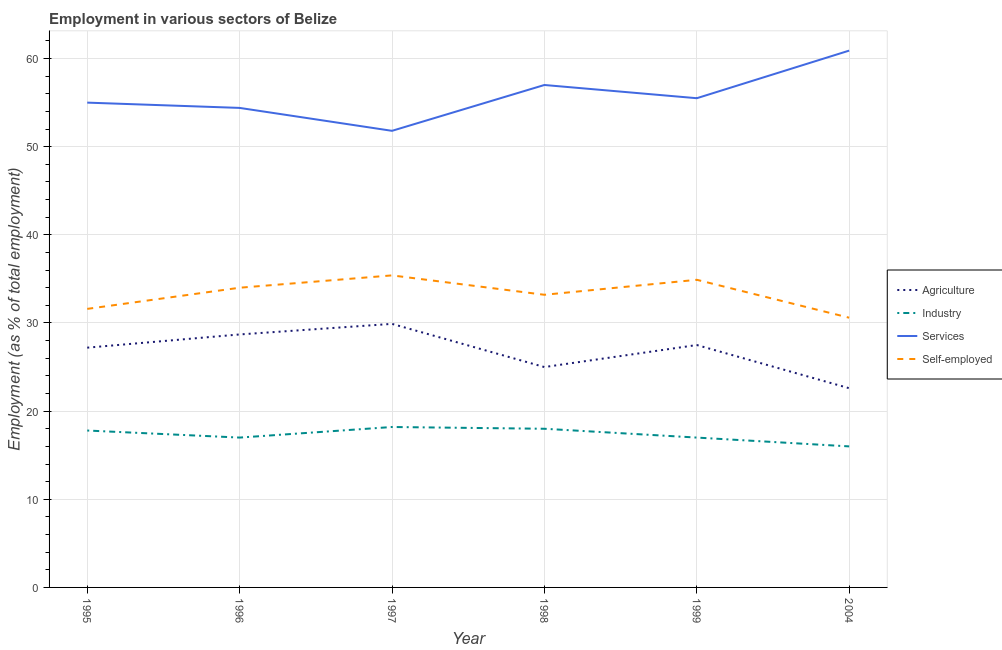Does the line corresponding to percentage of workers in services intersect with the line corresponding to percentage of workers in agriculture?
Ensure brevity in your answer.  No. What is the percentage of workers in industry in 1998?
Offer a very short reply. 18. Across all years, what is the maximum percentage of workers in services?
Ensure brevity in your answer.  60.9. Across all years, what is the minimum percentage of self employed workers?
Your response must be concise. 30.6. In which year was the percentage of self employed workers minimum?
Make the answer very short. 2004. What is the total percentage of self employed workers in the graph?
Offer a very short reply. 199.7. What is the difference between the percentage of self employed workers in 1998 and that in 1999?
Keep it short and to the point. -1.7. What is the difference between the percentage of workers in services in 1997 and the percentage of workers in industry in 2004?
Ensure brevity in your answer.  35.8. What is the average percentage of workers in industry per year?
Offer a very short reply. 17.33. In the year 1996, what is the difference between the percentage of workers in agriculture and percentage of workers in industry?
Provide a short and direct response. 11.7. What is the ratio of the percentage of self employed workers in 1995 to that in 1996?
Give a very brief answer. 0.93. Is the percentage of workers in services in 1995 less than that in 1996?
Keep it short and to the point. No. What is the difference between the highest and the second highest percentage of workers in agriculture?
Keep it short and to the point. 1.2. What is the difference between the highest and the lowest percentage of workers in industry?
Ensure brevity in your answer.  2.2. Is the percentage of self employed workers strictly greater than the percentage of workers in industry over the years?
Offer a very short reply. Yes. Is the percentage of workers in agriculture strictly less than the percentage of workers in industry over the years?
Your answer should be very brief. No. How many lines are there?
Provide a succinct answer. 4. How many years are there in the graph?
Keep it short and to the point. 6. What is the difference between two consecutive major ticks on the Y-axis?
Give a very brief answer. 10. Are the values on the major ticks of Y-axis written in scientific E-notation?
Offer a terse response. No. Does the graph contain any zero values?
Offer a very short reply. No. Where does the legend appear in the graph?
Offer a very short reply. Center right. What is the title of the graph?
Provide a short and direct response. Employment in various sectors of Belize. Does "Natural Gas" appear as one of the legend labels in the graph?
Offer a very short reply. No. What is the label or title of the X-axis?
Give a very brief answer. Year. What is the label or title of the Y-axis?
Give a very brief answer. Employment (as % of total employment). What is the Employment (as % of total employment) in Agriculture in 1995?
Ensure brevity in your answer.  27.2. What is the Employment (as % of total employment) in Industry in 1995?
Ensure brevity in your answer.  17.8. What is the Employment (as % of total employment) in Services in 1995?
Your answer should be compact. 55. What is the Employment (as % of total employment) in Self-employed in 1995?
Your answer should be compact. 31.6. What is the Employment (as % of total employment) in Agriculture in 1996?
Provide a short and direct response. 28.7. What is the Employment (as % of total employment) in Industry in 1996?
Offer a terse response. 17. What is the Employment (as % of total employment) of Services in 1996?
Your answer should be very brief. 54.4. What is the Employment (as % of total employment) in Agriculture in 1997?
Offer a very short reply. 29.9. What is the Employment (as % of total employment) in Industry in 1997?
Your answer should be compact. 18.2. What is the Employment (as % of total employment) of Services in 1997?
Provide a short and direct response. 51.8. What is the Employment (as % of total employment) in Self-employed in 1997?
Provide a succinct answer. 35.4. What is the Employment (as % of total employment) of Agriculture in 1998?
Provide a succinct answer. 25. What is the Employment (as % of total employment) of Industry in 1998?
Make the answer very short. 18. What is the Employment (as % of total employment) of Services in 1998?
Ensure brevity in your answer.  57. What is the Employment (as % of total employment) in Self-employed in 1998?
Your response must be concise. 33.2. What is the Employment (as % of total employment) in Agriculture in 1999?
Ensure brevity in your answer.  27.5. What is the Employment (as % of total employment) in Industry in 1999?
Make the answer very short. 17. What is the Employment (as % of total employment) of Services in 1999?
Provide a short and direct response. 55.5. What is the Employment (as % of total employment) in Self-employed in 1999?
Ensure brevity in your answer.  34.9. What is the Employment (as % of total employment) of Agriculture in 2004?
Make the answer very short. 22.6. What is the Employment (as % of total employment) in Industry in 2004?
Keep it short and to the point. 16. What is the Employment (as % of total employment) in Services in 2004?
Your response must be concise. 60.9. What is the Employment (as % of total employment) in Self-employed in 2004?
Give a very brief answer. 30.6. Across all years, what is the maximum Employment (as % of total employment) of Agriculture?
Offer a terse response. 29.9. Across all years, what is the maximum Employment (as % of total employment) in Industry?
Provide a succinct answer. 18.2. Across all years, what is the maximum Employment (as % of total employment) in Services?
Ensure brevity in your answer.  60.9. Across all years, what is the maximum Employment (as % of total employment) of Self-employed?
Your answer should be compact. 35.4. Across all years, what is the minimum Employment (as % of total employment) in Agriculture?
Make the answer very short. 22.6. Across all years, what is the minimum Employment (as % of total employment) in Services?
Keep it short and to the point. 51.8. Across all years, what is the minimum Employment (as % of total employment) in Self-employed?
Provide a short and direct response. 30.6. What is the total Employment (as % of total employment) in Agriculture in the graph?
Your response must be concise. 160.9. What is the total Employment (as % of total employment) of Industry in the graph?
Ensure brevity in your answer.  104. What is the total Employment (as % of total employment) in Services in the graph?
Your answer should be compact. 334.6. What is the total Employment (as % of total employment) in Self-employed in the graph?
Keep it short and to the point. 199.7. What is the difference between the Employment (as % of total employment) in Industry in 1995 and that in 1996?
Your answer should be very brief. 0.8. What is the difference between the Employment (as % of total employment) of Agriculture in 1995 and that in 1997?
Your answer should be very brief. -2.7. What is the difference between the Employment (as % of total employment) in Industry in 1995 and that in 1997?
Make the answer very short. -0.4. What is the difference between the Employment (as % of total employment) in Self-employed in 1995 and that in 1997?
Offer a very short reply. -3.8. What is the difference between the Employment (as % of total employment) in Agriculture in 1995 and that in 1998?
Ensure brevity in your answer.  2.2. What is the difference between the Employment (as % of total employment) of Industry in 1995 and that in 1998?
Make the answer very short. -0.2. What is the difference between the Employment (as % of total employment) in Services in 1995 and that in 1998?
Give a very brief answer. -2. What is the difference between the Employment (as % of total employment) of Self-employed in 1995 and that in 1998?
Your answer should be compact. -1.6. What is the difference between the Employment (as % of total employment) in Industry in 1995 and that in 1999?
Ensure brevity in your answer.  0.8. What is the difference between the Employment (as % of total employment) of Services in 1995 and that in 1999?
Your answer should be compact. -0.5. What is the difference between the Employment (as % of total employment) of Services in 1995 and that in 2004?
Ensure brevity in your answer.  -5.9. What is the difference between the Employment (as % of total employment) in Self-employed in 1995 and that in 2004?
Keep it short and to the point. 1. What is the difference between the Employment (as % of total employment) of Agriculture in 1996 and that in 1997?
Ensure brevity in your answer.  -1.2. What is the difference between the Employment (as % of total employment) of Industry in 1996 and that in 1997?
Ensure brevity in your answer.  -1.2. What is the difference between the Employment (as % of total employment) of Agriculture in 1996 and that in 1998?
Your answer should be compact. 3.7. What is the difference between the Employment (as % of total employment) in Services in 1996 and that in 1998?
Your answer should be compact. -2.6. What is the difference between the Employment (as % of total employment) of Agriculture in 1996 and that in 1999?
Your answer should be compact. 1.2. What is the difference between the Employment (as % of total employment) in Industry in 1996 and that in 1999?
Offer a terse response. 0. What is the difference between the Employment (as % of total employment) in Industry in 1996 and that in 2004?
Your answer should be compact. 1. What is the difference between the Employment (as % of total employment) in Industry in 1997 and that in 1998?
Your answer should be compact. 0.2. What is the difference between the Employment (as % of total employment) of Industry in 1997 and that in 1999?
Provide a succinct answer. 1.2. What is the difference between the Employment (as % of total employment) in Services in 1997 and that in 1999?
Provide a succinct answer. -3.7. What is the difference between the Employment (as % of total employment) of Services in 1997 and that in 2004?
Keep it short and to the point. -9.1. What is the difference between the Employment (as % of total employment) in Self-employed in 1997 and that in 2004?
Your response must be concise. 4.8. What is the difference between the Employment (as % of total employment) in Industry in 1998 and that in 1999?
Your answer should be compact. 1. What is the difference between the Employment (as % of total employment) of Services in 1998 and that in 1999?
Your answer should be very brief. 1.5. What is the difference between the Employment (as % of total employment) of Services in 1998 and that in 2004?
Give a very brief answer. -3.9. What is the difference between the Employment (as % of total employment) of Self-employed in 1998 and that in 2004?
Ensure brevity in your answer.  2.6. What is the difference between the Employment (as % of total employment) in Industry in 1999 and that in 2004?
Give a very brief answer. 1. What is the difference between the Employment (as % of total employment) in Services in 1999 and that in 2004?
Your response must be concise. -5.4. What is the difference between the Employment (as % of total employment) in Self-employed in 1999 and that in 2004?
Provide a short and direct response. 4.3. What is the difference between the Employment (as % of total employment) of Agriculture in 1995 and the Employment (as % of total employment) of Services in 1996?
Keep it short and to the point. -27.2. What is the difference between the Employment (as % of total employment) of Agriculture in 1995 and the Employment (as % of total employment) of Self-employed in 1996?
Offer a terse response. -6.8. What is the difference between the Employment (as % of total employment) of Industry in 1995 and the Employment (as % of total employment) of Services in 1996?
Offer a very short reply. -36.6. What is the difference between the Employment (as % of total employment) of Industry in 1995 and the Employment (as % of total employment) of Self-employed in 1996?
Your response must be concise. -16.2. What is the difference between the Employment (as % of total employment) of Services in 1995 and the Employment (as % of total employment) of Self-employed in 1996?
Your answer should be very brief. 21. What is the difference between the Employment (as % of total employment) of Agriculture in 1995 and the Employment (as % of total employment) of Industry in 1997?
Give a very brief answer. 9. What is the difference between the Employment (as % of total employment) of Agriculture in 1995 and the Employment (as % of total employment) of Services in 1997?
Your answer should be compact. -24.6. What is the difference between the Employment (as % of total employment) of Agriculture in 1995 and the Employment (as % of total employment) of Self-employed in 1997?
Your answer should be very brief. -8.2. What is the difference between the Employment (as % of total employment) of Industry in 1995 and the Employment (as % of total employment) of Services in 1997?
Provide a succinct answer. -34. What is the difference between the Employment (as % of total employment) of Industry in 1995 and the Employment (as % of total employment) of Self-employed in 1997?
Offer a very short reply. -17.6. What is the difference between the Employment (as % of total employment) in Services in 1995 and the Employment (as % of total employment) in Self-employed in 1997?
Make the answer very short. 19.6. What is the difference between the Employment (as % of total employment) in Agriculture in 1995 and the Employment (as % of total employment) in Services in 1998?
Provide a short and direct response. -29.8. What is the difference between the Employment (as % of total employment) in Industry in 1995 and the Employment (as % of total employment) in Services in 1998?
Offer a very short reply. -39.2. What is the difference between the Employment (as % of total employment) in Industry in 1995 and the Employment (as % of total employment) in Self-employed in 1998?
Provide a short and direct response. -15.4. What is the difference between the Employment (as % of total employment) of Services in 1995 and the Employment (as % of total employment) of Self-employed in 1998?
Ensure brevity in your answer.  21.8. What is the difference between the Employment (as % of total employment) in Agriculture in 1995 and the Employment (as % of total employment) in Industry in 1999?
Offer a very short reply. 10.2. What is the difference between the Employment (as % of total employment) in Agriculture in 1995 and the Employment (as % of total employment) in Services in 1999?
Offer a terse response. -28.3. What is the difference between the Employment (as % of total employment) of Agriculture in 1995 and the Employment (as % of total employment) of Self-employed in 1999?
Your response must be concise. -7.7. What is the difference between the Employment (as % of total employment) in Industry in 1995 and the Employment (as % of total employment) in Services in 1999?
Ensure brevity in your answer.  -37.7. What is the difference between the Employment (as % of total employment) of Industry in 1995 and the Employment (as % of total employment) of Self-employed in 1999?
Offer a very short reply. -17.1. What is the difference between the Employment (as % of total employment) of Services in 1995 and the Employment (as % of total employment) of Self-employed in 1999?
Your answer should be compact. 20.1. What is the difference between the Employment (as % of total employment) of Agriculture in 1995 and the Employment (as % of total employment) of Services in 2004?
Offer a very short reply. -33.7. What is the difference between the Employment (as % of total employment) of Industry in 1995 and the Employment (as % of total employment) of Services in 2004?
Your response must be concise. -43.1. What is the difference between the Employment (as % of total employment) in Industry in 1995 and the Employment (as % of total employment) in Self-employed in 2004?
Keep it short and to the point. -12.8. What is the difference between the Employment (as % of total employment) of Services in 1995 and the Employment (as % of total employment) of Self-employed in 2004?
Provide a succinct answer. 24.4. What is the difference between the Employment (as % of total employment) of Agriculture in 1996 and the Employment (as % of total employment) of Services in 1997?
Ensure brevity in your answer.  -23.1. What is the difference between the Employment (as % of total employment) of Agriculture in 1996 and the Employment (as % of total employment) of Self-employed in 1997?
Offer a terse response. -6.7. What is the difference between the Employment (as % of total employment) in Industry in 1996 and the Employment (as % of total employment) in Services in 1997?
Keep it short and to the point. -34.8. What is the difference between the Employment (as % of total employment) in Industry in 1996 and the Employment (as % of total employment) in Self-employed in 1997?
Provide a short and direct response. -18.4. What is the difference between the Employment (as % of total employment) of Services in 1996 and the Employment (as % of total employment) of Self-employed in 1997?
Your answer should be compact. 19. What is the difference between the Employment (as % of total employment) of Agriculture in 1996 and the Employment (as % of total employment) of Industry in 1998?
Offer a terse response. 10.7. What is the difference between the Employment (as % of total employment) of Agriculture in 1996 and the Employment (as % of total employment) of Services in 1998?
Your answer should be very brief. -28.3. What is the difference between the Employment (as % of total employment) in Agriculture in 1996 and the Employment (as % of total employment) in Self-employed in 1998?
Your answer should be compact. -4.5. What is the difference between the Employment (as % of total employment) of Industry in 1996 and the Employment (as % of total employment) of Services in 1998?
Make the answer very short. -40. What is the difference between the Employment (as % of total employment) of Industry in 1996 and the Employment (as % of total employment) of Self-employed in 1998?
Provide a succinct answer. -16.2. What is the difference between the Employment (as % of total employment) of Services in 1996 and the Employment (as % of total employment) of Self-employed in 1998?
Your answer should be very brief. 21.2. What is the difference between the Employment (as % of total employment) of Agriculture in 1996 and the Employment (as % of total employment) of Industry in 1999?
Offer a terse response. 11.7. What is the difference between the Employment (as % of total employment) of Agriculture in 1996 and the Employment (as % of total employment) of Services in 1999?
Offer a very short reply. -26.8. What is the difference between the Employment (as % of total employment) in Industry in 1996 and the Employment (as % of total employment) in Services in 1999?
Provide a short and direct response. -38.5. What is the difference between the Employment (as % of total employment) in Industry in 1996 and the Employment (as % of total employment) in Self-employed in 1999?
Keep it short and to the point. -17.9. What is the difference between the Employment (as % of total employment) of Services in 1996 and the Employment (as % of total employment) of Self-employed in 1999?
Offer a terse response. 19.5. What is the difference between the Employment (as % of total employment) in Agriculture in 1996 and the Employment (as % of total employment) in Industry in 2004?
Offer a very short reply. 12.7. What is the difference between the Employment (as % of total employment) in Agriculture in 1996 and the Employment (as % of total employment) in Services in 2004?
Keep it short and to the point. -32.2. What is the difference between the Employment (as % of total employment) of Industry in 1996 and the Employment (as % of total employment) of Services in 2004?
Keep it short and to the point. -43.9. What is the difference between the Employment (as % of total employment) in Industry in 1996 and the Employment (as % of total employment) in Self-employed in 2004?
Offer a very short reply. -13.6. What is the difference between the Employment (as % of total employment) in Services in 1996 and the Employment (as % of total employment) in Self-employed in 2004?
Offer a terse response. 23.8. What is the difference between the Employment (as % of total employment) of Agriculture in 1997 and the Employment (as % of total employment) of Services in 1998?
Keep it short and to the point. -27.1. What is the difference between the Employment (as % of total employment) of Industry in 1997 and the Employment (as % of total employment) of Services in 1998?
Provide a short and direct response. -38.8. What is the difference between the Employment (as % of total employment) in Services in 1997 and the Employment (as % of total employment) in Self-employed in 1998?
Keep it short and to the point. 18.6. What is the difference between the Employment (as % of total employment) of Agriculture in 1997 and the Employment (as % of total employment) of Services in 1999?
Keep it short and to the point. -25.6. What is the difference between the Employment (as % of total employment) in Industry in 1997 and the Employment (as % of total employment) in Services in 1999?
Offer a very short reply. -37.3. What is the difference between the Employment (as % of total employment) in Industry in 1997 and the Employment (as % of total employment) in Self-employed in 1999?
Provide a succinct answer. -16.7. What is the difference between the Employment (as % of total employment) of Services in 1997 and the Employment (as % of total employment) of Self-employed in 1999?
Your answer should be very brief. 16.9. What is the difference between the Employment (as % of total employment) in Agriculture in 1997 and the Employment (as % of total employment) in Services in 2004?
Offer a very short reply. -31. What is the difference between the Employment (as % of total employment) of Industry in 1997 and the Employment (as % of total employment) of Services in 2004?
Ensure brevity in your answer.  -42.7. What is the difference between the Employment (as % of total employment) of Industry in 1997 and the Employment (as % of total employment) of Self-employed in 2004?
Ensure brevity in your answer.  -12.4. What is the difference between the Employment (as % of total employment) in Services in 1997 and the Employment (as % of total employment) in Self-employed in 2004?
Your answer should be very brief. 21.2. What is the difference between the Employment (as % of total employment) of Agriculture in 1998 and the Employment (as % of total employment) of Services in 1999?
Your response must be concise. -30.5. What is the difference between the Employment (as % of total employment) of Industry in 1998 and the Employment (as % of total employment) of Services in 1999?
Your response must be concise. -37.5. What is the difference between the Employment (as % of total employment) of Industry in 1998 and the Employment (as % of total employment) of Self-employed in 1999?
Ensure brevity in your answer.  -16.9. What is the difference between the Employment (as % of total employment) in Services in 1998 and the Employment (as % of total employment) in Self-employed in 1999?
Provide a short and direct response. 22.1. What is the difference between the Employment (as % of total employment) in Agriculture in 1998 and the Employment (as % of total employment) in Services in 2004?
Make the answer very short. -35.9. What is the difference between the Employment (as % of total employment) of Industry in 1998 and the Employment (as % of total employment) of Services in 2004?
Offer a terse response. -42.9. What is the difference between the Employment (as % of total employment) in Services in 1998 and the Employment (as % of total employment) in Self-employed in 2004?
Keep it short and to the point. 26.4. What is the difference between the Employment (as % of total employment) in Agriculture in 1999 and the Employment (as % of total employment) in Industry in 2004?
Provide a succinct answer. 11.5. What is the difference between the Employment (as % of total employment) in Agriculture in 1999 and the Employment (as % of total employment) in Services in 2004?
Your response must be concise. -33.4. What is the difference between the Employment (as % of total employment) in Agriculture in 1999 and the Employment (as % of total employment) in Self-employed in 2004?
Provide a short and direct response. -3.1. What is the difference between the Employment (as % of total employment) in Industry in 1999 and the Employment (as % of total employment) in Services in 2004?
Offer a very short reply. -43.9. What is the difference between the Employment (as % of total employment) in Industry in 1999 and the Employment (as % of total employment) in Self-employed in 2004?
Offer a terse response. -13.6. What is the difference between the Employment (as % of total employment) in Services in 1999 and the Employment (as % of total employment) in Self-employed in 2004?
Your response must be concise. 24.9. What is the average Employment (as % of total employment) in Agriculture per year?
Keep it short and to the point. 26.82. What is the average Employment (as % of total employment) in Industry per year?
Provide a short and direct response. 17.33. What is the average Employment (as % of total employment) in Services per year?
Keep it short and to the point. 55.77. What is the average Employment (as % of total employment) of Self-employed per year?
Your answer should be compact. 33.28. In the year 1995, what is the difference between the Employment (as % of total employment) of Agriculture and Employment (as % of total employment) of Services?
Keep it short and to the point. -27.8. In the year 1995, what is the difference between the Employment (as % of total employment) of Industry and Employment (as % of total employment) of Services?
Keep it short and to the point. -37.2. In the year 1995, what is the difference between the Employment (as % of total employment) in Services and Employment (as % of total employment) in Self-employed?
Your response must be concise. 23.4. In the year 1996, what is the difference between the Employment (as % of total employment) of Agriculture and Employment (as % of total employment) of Industry?
Provide a succinct answer. 11.7. In the year 1996, what is the difference between the Employment (as % of total employment) in Agriculture and Employment (as % of total employment) in Services?
Ensure brevity in your answer.  -25.7. In the year 1996, what is the difference between the Employment (as % of total employment) in Agriculture and Employment (as % of total employment) in Self-employed?
Ensure brevity in your answer.  -5.3. In the year 1996, what is the difference between the Employment (as % of total employment) of Industry and Employment (as % of total employment) of Services?
Make the answer very short. -37.4. In the year 1996, what is the difference between the Employment (as % of total employment) of Industry and Employment (as % of total employment) of Self-employed?
Provide a succinct answer. -17. In the year 1996, what is the difference between the Employment (as % of total employment) of Services and Employment (as % of total employment) of Self-employed?
Your answer should be compact. 20.4. In the year 1997, what is the difference between the Employment (as % of total employment) of Agriculture and Employment (as % of total employment) of Industry?
Your answer should be very brief. 11.7. In the year 1997, what is the difference between the Employment (as % of total employment) of Agriculture and Employment (as % of total employment) of Services?
Give a very brief answer. -21.9. In the year 1997, what is the difference between the Employment (as % of total employment) in Agriculture and Employment (as % of total employment) in Self-employed?
Your response must be concise. -5.5. In the year 1997, what is the difference between the Employment (as % of total employment) in Industry and Employment (as % of total employment) in Services?
Your answer should be very brief. -33.6. In the year 1997, what is the difference between the Employment (as % of total employment) of Industry and Employment (as % of total employment) of Self-employed?
Offer a terse response. -17.2. In the year 1998, what is the difference between the Employment (as % of total employment) in Agriculture and Employment (as % of total employment) in Industry?
Offer a very short reply. 7. In the year 1998, what is the difference between the Employment (as % of total employment) of Agriculture and Employment (as % of total employment) of Services?
Offer a very short reply. -32. In the year 1998, what is the difference between the Employment (as % of total employment) in Agriculture and Employment (as % of total employment) in Self-employed?
Provide a short and direct response. -8.2. In the year 1998, what is the difference between the Employment (as % of total employment) of Industry and Employment (as % of total employment) of Services?
Provide a succinct answer. -39. In the year 1998, what is the difference between the Employment (as % of total employment) of Industry and Employment (as % of total employment) of Self-employed?
Ensure brevity in your answer.  -15.2. In the year 1998, what is the difference between the Employment (as % of total employment) of Services and Employment (as % of total employment) of Self-employed?
Your answer should be compact. 23.8. In the year 1999, what is the difference between the Employment (as % of total employment) of Agriculture and Employment (as % of total employment) of Industry?
Your answer should be very brief. 10.5. In the year 1999, what is the difference between the Employment (as % of total employment) of Agriculture and Employment (as % of total employment) of Services?
Give a very brief answer. -28. In the year 1999, what is the difference between the Employment (as % of total employment) of Industry and Employment (as % of total employment) of Services?
Offer a very short reply. -38.5. In the year 1999, what is the difference between the Employment (as % of total employment) in Industry and Employment (as % of total employment) in Self-employed?
Your response must be concise. -17.9. In the year 1999, what is the difference between the Employment (as % of total employment) in Services and Employment (as % of total employment) in Self-employed?
Offer a terse response. 20.6. In the year 2004, what is the difference between the Employment (as % of total employment) in Agriculture and Employment (as % of total employment) in Services?
Your answer should be very brief. -38.3. In the year 2004, what is the difference between the Employment (as % of total employment) in Industry and Employment (as % of total employment) in Services?
Your answer should be very brief. -44.9. In the year 2004, what is the difference between the Employment (as % of total employment) in Industry and Employment (as % of total employment) in Self-employed?
Ensure brevity in your answer.  -14.6. In the year 2004, what is the difference between the Employment (as % of total employment) in Services and Employment (as % of total employment) in Self-employed?
Your response must be concise. 30.3. What is the ratio of the Employment (as % of total employment) of Agriculture in 1995 to that in 1996?
Your answer should be compact. 0.95. What is the ratio of the Employment (as % of total employment) of Industry in 1995 to that in 1996?
Offer a terse response. 1.05. What is the ratio of the Employment (as % of total employment) of Services in 1995 to that in 1996?
Your response must be concise. 1.01. What is the ratio of the Employment (as % of total employment) of Self-employed in 1995 to that in 1996?
Your response must be concise. 0.93. What is the ratio of the Employment (as % of total employment) in Agriculture in 1995 to that in 1997?
Provide a short and direct response. 0.91. What is the ratio of the Employment (as % of total employment) of Industry in 1995 to that in 1997?
Provide a succinct answer. 0.98. What is the ratio of the Employment (as % of total employment) in Services in 1995 to that in 1997?
Keep it short and to the point. 1.06. What is the ratio of the Employment (as % of total employment) of Self-employed in 1995 to that in 1997?
Offer a very short reply. 0.89. What is the ratio of the Employment (as % of total employment) of Agriculture in 1995 to that in 1998?
Give a very brief answer. 1.09. What is the ratio of the Employment (as % of total employment) in Industry in 1995 to that in 1998?
Give a very brief answer. 0.99. What is the ratio of the Employment (as % of total employment) in Services in 1995 to that in 1998?
Make the answer very short. 0.96. What is the ratio of the Employment (as % of total employment) in Self-employed in 1995 to that in 1998?
Ensure brevity in your answer.  0.95. What is the ratio of the Employment (as % of total employment) in Agriculture in 1995 to that in 1999?
Make the answer very short. 0.99. What is the ratio of the Employment (as % of total employment) of Industry in 1995 to that in 1999?
Provide a succinct answer. 1.05. What is the ratio of the Employment (as % of total employment) of Self-employed in 1995 to that in 1999?
Your answer should be compact. 0.91. What is the ratio of the Employment (as % of total employment) of Agriculture in 1995 to that in 2004?
Make the answer very short. 1.2. What is the ratio of the Employment (as % of total employment) of Industry in 1995 to that in 2004?
Your answer should be compact. 1.11. What is the ratio of the Employment (as % of total employment) of Services in 1995 to that in 2004?
Make the answer very short. 0.9. What is the ratio of the Employment (as % of total employment) in Self-employed in 1995 to that in 2004?
Keep it short and to the point. 1.03. What is the ratio of the Employment (as % of total employment) in Agriculture in 1996 to that in 1997?
Keep it short and to the point. 0.96. What is the ratio of the Employment (as % of total employment) in Industry in 1996 to that in 1997?
Your answer should be compact. 0.93. What is the ratio of the Employment (as % of total employment) in Services in 1996 to that in 1997?
Your answer should be very brief. 1.05. What is the ratio of the Employment (as % of total employment) in Self-employed in 1996 to that in 1997?
Ensure brevity in your answer.  0.96. What is the ratio of the Employment (as % of total employment) of Agriculture in 1996 to that in 1998?
Your answer should be compact. 1.15. What is the ratio of the Employment (as % of total employment) of Services in 1996 to that in 1998?
Make the answer very short. 0.95. What is the ratio of the Employment (as % of total employment) in Self-employed in 1996 to that in 1998?
Give a very brief answer. 1.02. What is the ratio of the Employment (as % of total employment) of Agriculture in 1996 to that in 1999?
Your answer should be very brief. 1.04. What is the ratio of the Employment (as % of total employment) in Industry in 1996 to that in 1999?
Ensure brevity in your answer.  1. What is the ratio of the Employment (as % of total employment) in Services in 1996 to that in 1999?
Give a very brief answer. 0.98. What is the ratio of the Employment (as % of total employment) of Self-employed in 1996 to that in 1999?
Give a very brief answer. 0.97. What is the ratio of the Employment (as % of total employment) in Agriculture in 1996 to that in 2004?
Offer a terse response. 1.27. What is the ratio of the Employment (as % of total employment) in Services in 1996 to that in 2004?
Ensure brevity in your answer.  0.89. What is the ratio of the Employment (as % of total employment) in Agriculture in 1997 to that in 1998?
Offer a very short reply. 1.2. What is the ratio of the Employment (as % of total employment) of Industry in 1997 to that in 1998?
Keep it short and to the point. 1.01. What is the ratio of the Employment (as % of total employment) in Services in 1997 to that in 1998?
Offer a very short reply. 0.91. What is the ratio of the Employment (as % of total employment) in Self-employed in 1997 to that in 1998?
Offer a terse response. 1.07. What is the ratio of the Employment (as % of total employment) of Agriculture in 1997 to that in 1999?
Offer a terse response. 1.09. What is the ratio of the Employment (as % of total employment) in Industry in 1997 to that in 1999?
Offer a very short reply. 1.07. What is the ratio of the Employment (as % of total employment) of Services in 1997 to that in 1999?
Offer a terse response. 0.93. What is the ratio of the Employment (as % of total employment) of Self-employed in 1997 to that in 1999?
Offer a very short reply. 1.01. What is the ratio of the Employment (as % of total employment) in Agriculture in 1997 to that in 2004?
Give a very brief answer. 1.32. What is the ratio of the Employment (as % of total employment) in Industry in 1997 to that in 2004?
Provide a succinct answer. 1.14. What is the ratio of the Employment (as % of total employment) of Services in 1997 to that in 2004?
Your answer should be compact. 0.85. What is the ratio of the Employment (as % of total employment) in Self-employed in 1997 to that in 2004?
Provide a short and direct response. 1.16. What is the ratio of the Employment (as % of total employment) of Agriculture in 1998 to that in 1999?
Provide a succinct answer. 0.91. What is the ratio of the Employment (as % of total employment) in Industry in 1998 to that in 1999?
Offer a very short reply. 1.06. What is the ratio of the Employment (as % of total employment) of Self-employed in 1998 to that in 1999?
Make the answer very short. 0.95. What is the ratio of the Employment (as % of total employment) in Agriculture in 1998 to that in 2004?
Offer a very short reply. 1.11. What is the ratio of the Employment (as % of total employment) in Industry in 1998 to that in 2004?
Keep it short and to the point. 1.12. What is the ratio of the Employment (as % of total employment) of Services in 1998 to that in 2004?
Your answer should be compact. 0.94. What is the ratio of the Employment (as % of total employment) in Self-employed in 1998 to that in 2004?
Make the answer very short. 1.08. What is the ratio of the Employment (as % of total employment) of Agriculture in 1999 to that in 2004?
Give a very brief answer. 1.22. What is the ratio of the Employment (as % of total employment) in Services in 1999 to that in 2004?
Keep it short and to the point. 0.91. What is the ratio of the Employment (as % of total employment) of Self-employed in 1999 to that in 2004?
Give a very brief answer. 1.14. What is the difference between the highest and the second highest Employment (as % of total employment) of Industry?
Ensure brevity in your answer.  0.2. What is the difference between the highest and the second highest Employment (as % of total employment) in Services?
Keep it short and to the point. 3.9. What is the difference between the highest and the second highest Employment (as % of total employment) of Self-employed?
Provide a short and direct response. 0.5. What is the difference between the highest and the lowest Employment (as % of total employment) of Agriculture?
Provide a succinct answer. 7.3. What is the difference between the highest and the lowest Employment (as % of total employment) in Industry?
Your response must be concise. 2.2. What is the difference between the highest and the lowest Employment (as % of total employment) of Services?
Keep it short and to the point. 9.1. What is the difference between the highest and the lowest Employment (as % of total employment) in Self-employed?
Your response must be concise. 4.8. 